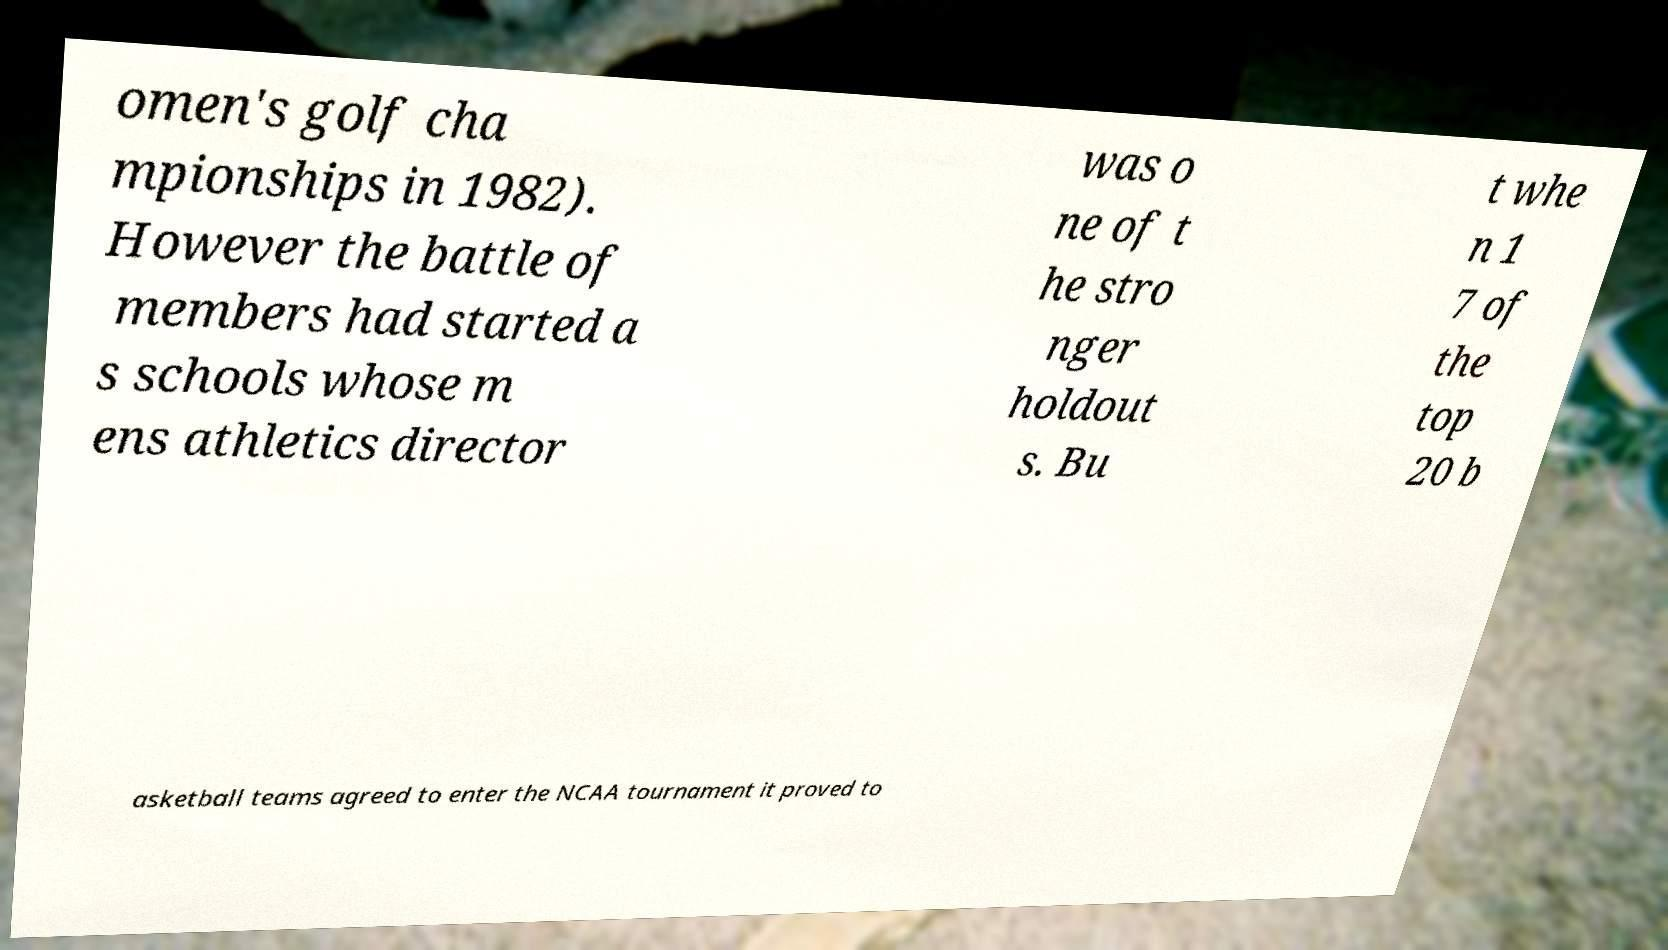Please identify and transcribe the text found in this image. omen's golf cha mpionships in 1982). However the battle of members had started a s schools whose m ens athletics director was o ne of t he stro nger holdout s. Bu t whe n 1 7 of the top 20 b asketball teams agreed to enter the NCAA tournament it proved to 